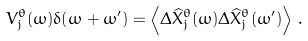Convert formula to latex. <formula><loc_0><loc_0><loc_500><loc_500>V ^ { \theta } _ { j } ( \omega ) \delta ( \omega + \omega ^ { \prime } ) = \left < \Delta \widehat { X } _ { j } ^ { \theta } ( \omega ) \Delta \widehat { X } _ { j } ^ { \theta } ( \omega ^ { \prime } ) \right > \, .</formula> 